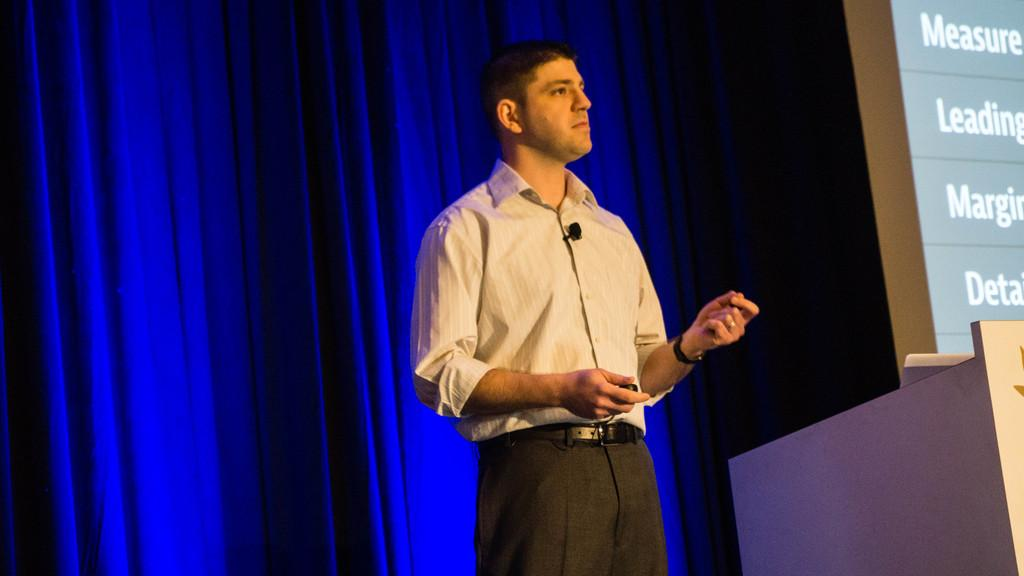What is the person in the image doing? The person is standing in front of a podium. What can be seen behind the person? There are curtains behind the person. What is displayed on the screen in the image? There is a screen with text on it in the image. How much chalk is being used by the person in the image? There is no chalk present in the image; the person is standing in front of a podium and there is a screen with text on it. 